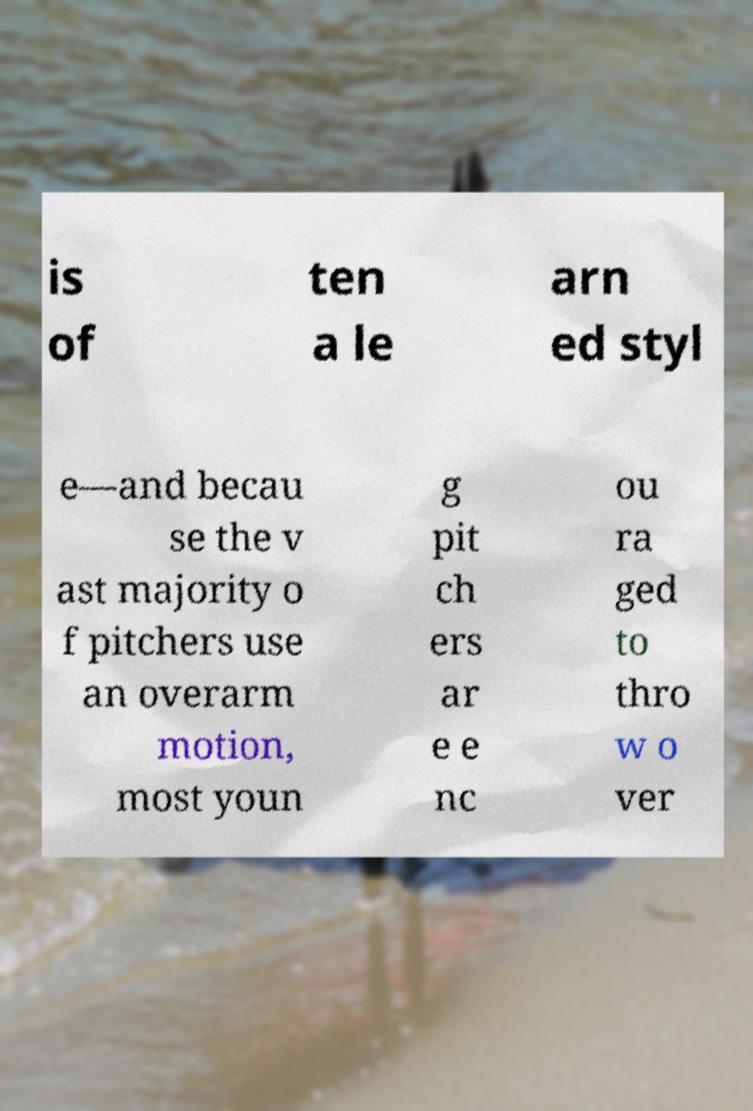I need the written content from this picture converted into text. Can you do that? is of ten a le arn ed styl e—and becau se the v ast majority o f pitchers use an overarm motion, most youn g pit ch ers ar e e nc ou ra ged to thro w o ver 